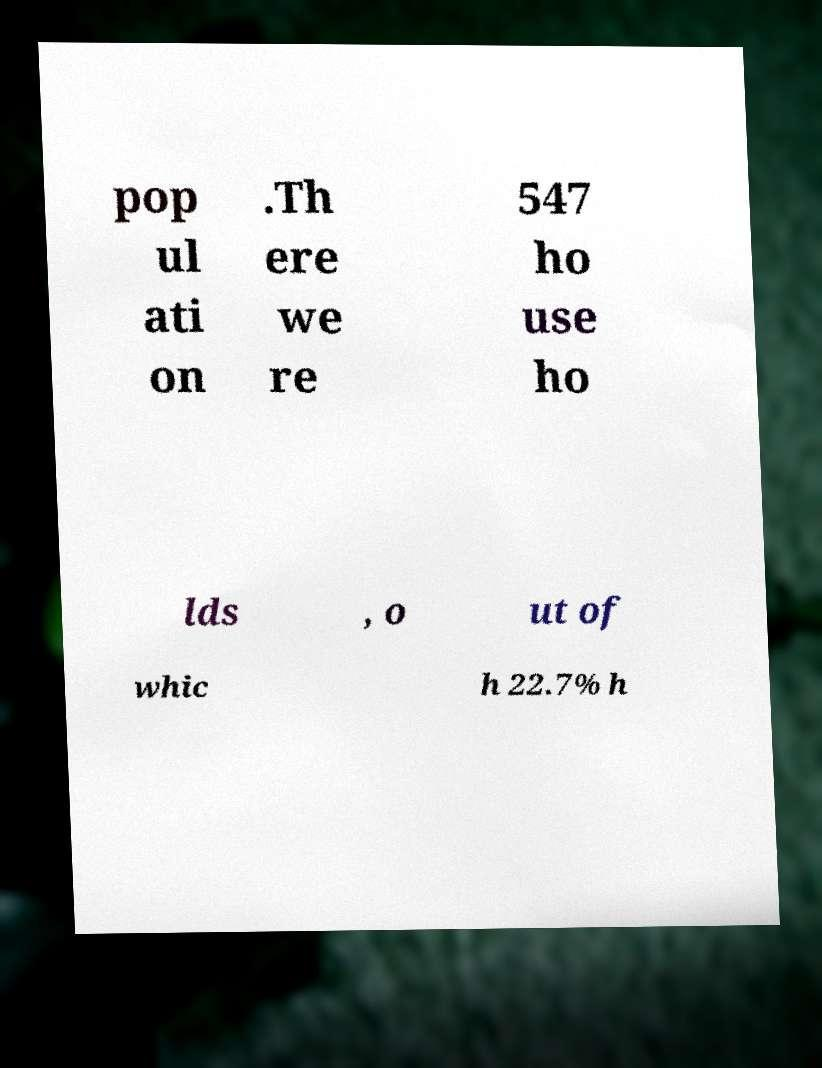For documentation purposes, I need the text within this image transcribed. Could you provide that? pop ul ati on .Th ere we re 547 ho use ho lds , o ut of whic h 22.7% h 